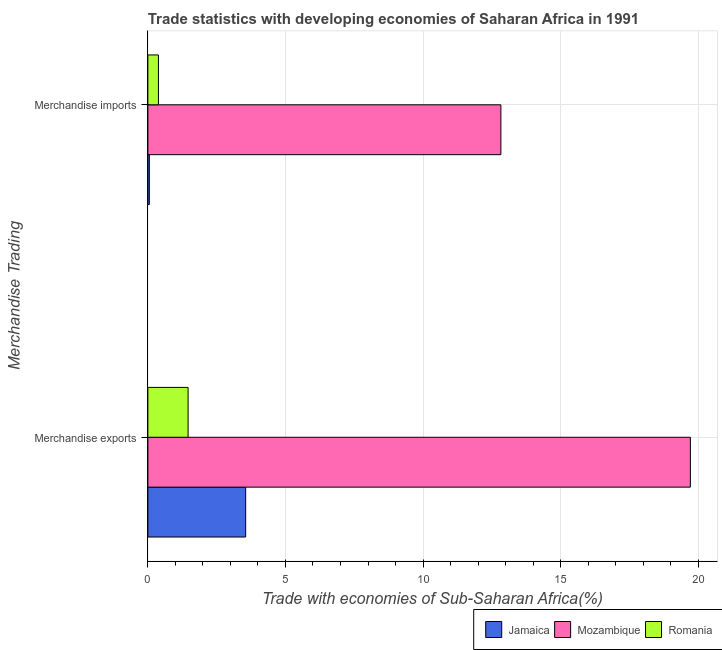How many different coloured bars are there?
Your response must be concise. 3. How many groups of bars are there?
Offer a terse response. 2. Are the number of bars per tick equal to the number of legend labels?
Keep it short and to the point. Yes. Are the number of bars on each tick of the Y-axis equal?
Your response must be concise. Yes. How many bars are there on the 1st tick from the top?
Make the answer very short. 3. How many bars are there on the 2nd tick from the bottom?
Give a very brief answer. 3. What is the merchandise exports in Mozambique?
Keep it short and to the point. 19.71. Across all countries, what is the maximum merchandise exports?
Your answer should be compact. 19.71. Across all countries, what is the minimum merchandise exports?
Give a very brief answer. 1.46. In which country was the merchandise exports maximum?
Provide a succinct answer. Mozambique. In which country was the merchandise exports minimum?
Your answer should be compact. Romania. What is the total merchandise imports in the graph?
Make the answer very short. 13.26. What is the difference between the merchandise imports in Romania and that in Jamaica?
Offer a terse response. 0.33. What is the difference between the merchandise imports in Mozambique and the merchandise exports in Romania?
Your answer should be compact. 11.37. What is the average merchandise imports per country?
Your response must be concise. 4.42. What is the difference between the merchandise imports and merchandise exports in Mozambique?
Your response must be concise. -6.89. In how many countries, is the merchandise exports greater than 7 %?
Offer a terse response. 1. What is the ratio of the merchandise imports in Jamaica to that in Mozambique?
Provide a succinct answer. 0. Is the merchandise imports in Jamaica less than that in Romania?
Your answer should be very brief. Yes. In how many countries, is the merchandise exports greater than the average merchandise exports taken over all countries?
Keep it short and to the point. 1. What does the 2nd bar from the top in Merchandise imports represents?
Your answer should be very brief. Mozambique. What does the 3rd bar from the bottom in Merchandise imports represents?
Your response must be concise. Romania. Are the values on the major ticks of X-axis written in scientific E-notation?
Your answer should be compact. No. Does the graph contain grids?
Provide a succinct answer. Yes. How many legend labels are there?
Provide a short and direct response. 3. What is the title of the graph?
Give a very brief answer. Trade statistics with developing economies of Saharan Africa in 1991. What is the label or title of the X-axis?
Offer a terse response. Trade with economies of Sub-Saharan Africa(%). What is the label or title of the Y-axis?
Your response must be concise. Merchandise Trading. What is the Trade with economies of Sub-Saharan Africa(%) in Jamaica in Merchandise exports?
Ensure brevity in your answer.  3.55. What is the Trade with economies of Sub-Saharan Africa(%) in Mozambique in Merchandise exports?
Ensure brevity in your answer.  19.71. What is the Trade with economies of Sub-Saharan Africa(%) in Romania in Merchandise exports?
Offer a terse response. 1.46. What is the Trade with economies of Sub-Saharan Africa(%) in Jamaica in Merchandise imports?
Keep it short and to the point. 0.05. What is the Trade with economies of Sub-Saharan Africa(%) in Mozambique in Merchandise imports?
Your answer should be very brief. 12.83. What is the Trade with economies of Sub-Saharan Africa(%) in Romania in Merchandise imports?
Your response must be concise. 0.38. Across all Merchandise Trading, what is the maximum Trade with economies of Sub-Saharan Africa(%) of Jamaica?
Offer a terse response. 3.55. Across all Merchandise Trading, what is the maximum Trade with economies of Sub-Saharan Africa(%) in Mozambique?
Offer a terse response. 19.71. Across all Merchandise Trading, what is the maximum Trade with economies of Sub-Saharan Africa(%) of Romania?
Your response must be concise. 1.46. Across all Merchandise Trading, what is the minimum Trade with economies of Sub-Saharan Africa(%) in Jamaica?
Provide a succinct answer. 0.05. Across all Merchandise Trading, what is the minimum Trade with economies of Sub-Saharan Africa(%) of Mozambique?
Give a very brief answer. 12.83. Across all Merchandise Trading, what is the minimum Trade with economies of Sub-Saharan Africa(%) in Romania?
Offer a terse response. 0.38. What is the total Trade with economies of Sub-Saharan Africa(%) in Jamaica in the graph?
Make the answer very short. 3.61. What is the total Trade with economies of Sub-Saharan Africa(%) of Mozambique in the graph?
Provide a succinct answer. 32.54. What is the total Trade with economies of Sub-Saharan Africa(%) of Romania in the graph?
Ensure brevity in your answer.  1.84. What is the difference between the Trade with economies of Sub-Saharan Africa(%) of Jamaica in Merchandise exports and that in Merchandise imports?
Your answer should be very brief. 3.5. What is the difference between the Trade with economies of Sub-Saharan Africa(%) of Mozambique in Merchandise exports and that in Merchandise imports?
Make the answer very short. 6.89. What is the difference between the Trade with economies of Sub-Saharan Africa(%) of Romania in Merchandise exports and that in Merchandise imports?
Give a very brief answer. 1.08. What is the difference between the Trade with economies of Sub-Saharan Africa(%) of Jamaica in Merchandise exports and the Trade with economies of Sub-Saharan Africa(%) of Mozambique in Merchandise imports?
Provide a succinct answer. -9.27. What is the difference between the Trade with economies of Sub-Saharan Africa(%) in Jamaica in Merchandise exports and the Trade with economies of Sub-Saharan Africa(%) in Romania in Merchandise imports?
Your answer should be very brief. 3.17. What is the difference between the Trade with economies of Sub-Saharan Africa(%) in Mozambique in Merchandise exports and the Trade with economies of Sub-Saharan Africa(%) in Romania in Merchandise imports?
Provide a short and direct response. 19.33. What is the average Trade with economies of Sub-Saharan Africa(%) of Jamaica per Merchandise Trading?
Ensure brevity in your answer.  1.8. What is the average Trade with economies of Sub-Saharan Africa(%) of Mozambique per Merchandise Trading?
Your answer should be very brief. 16.27. What is the average Trade with economies of Sub-Saharan Africa(%) of Romania per Merchandise Trading?
Your answer should be compact. 0.92. What is the difference between the Trade with economies of Sub-Saharan Africa(%) of Jamaica and Trade with economies of Sub-Saharan Africa(%) of Mozambique in Merchandise exports?
Your response must be concise. -16.16. What is the difference between the Trade with economies of Sub-Saharan Africa(%) of Jamaica and Trade with economies of Sub-Saharan Africa(%) of Romania in Merchandise exports?
Offer a very short reply. 2.09. What is the difference between the Trade with economies of Sub-Saharan Africa(%) in Mozambique and Trade with economies of Sub-Saharan Africa(%) in Romania in Merchandise exports?
Ensure brevity in your answer.  18.25. What is the difference between the Trade with economies of Sub-Saharan Africa(%) in Jamaica and Trade with economies of Sub-Saharan Africa(%) in Mozambique in Merchandise imports?
Provide a succinct answer. -12.77. What is the difference between the Trade with economies of Sub-Saharan Africa(%) of Jamaica and Trade with economies of Sub-Saharan Africa(%) of Romania in Merchandise imports?
Offer a terse response. -0.33. What is the difference between the Trade with economies of Sub-Saharan Africa(%) in Mozambique and Trade with economies of Sub-Saharan Africa(%) in Romania in Merchandise imports?
Provide a succinct answer. 12.44. What is the ratio of the Trade with economies of Sub-Saharan Africa(%) in Jamaica in Merchandise exports to that in Merchandise imports?
Your answer should be compact. 65.95. What is the ratio of the Trade with economies of Sub-Saharan Africa(%) of Mozambique in Merchandise exports to that in Merchandise imports?
Your answer should be very brief. 1.54. What is the ratio of the Trade with economies of Sub-Saharan Africa(%) of Romania in Merchandise exports to that in Merchandise imports?
Provide a short and direct response. 3.81. What is the difference between the highest and the second highest Trade with economies of Sub-Saharan Africa(%) of Jamaica?
Provide a short and direct response. 3.5. What is the difference between the highest and the second highest Trade with economies of Sub-Saharan Africa(%) in Mozambique?
Your answer should be very brief. 6.89. What is the difference between the highest and the second highest Trade with economies of Sub-Saharan Africa(%) of Romania?
Give a very brief answer. 1.08. What is the difference between the highest and the lowest Trade with economies of Sub-Saharan Africa(%) of Jamaica?
Your answer should be very brief. 3.5. What is the difference between the highest and the lowest Trade with economies of Sub-Saharan Africa(%) of Mozambique?
Your answer should be very brief. 6.89. What is the difference between the highest and the lowest Trade with economies of Sub-Saharan Africa(%) of Romania?
Offer a terse response. 1.08. 